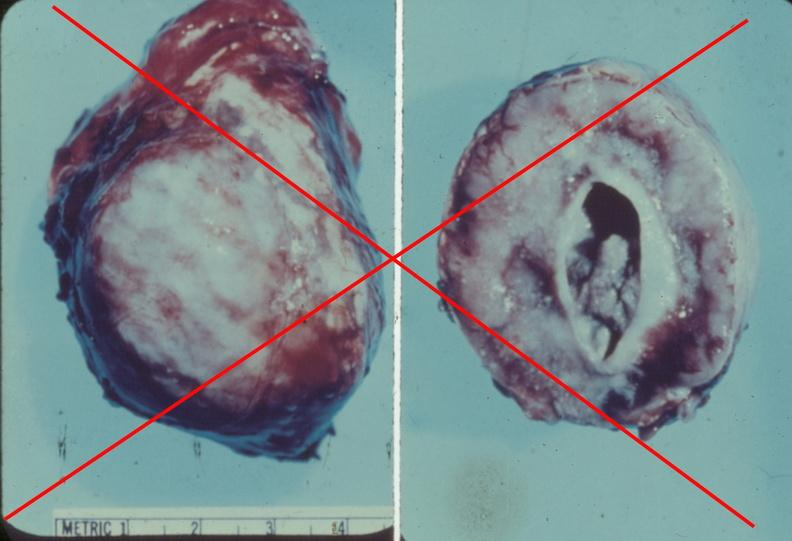s slide present?
Answer the question using a single word or phrase. No 